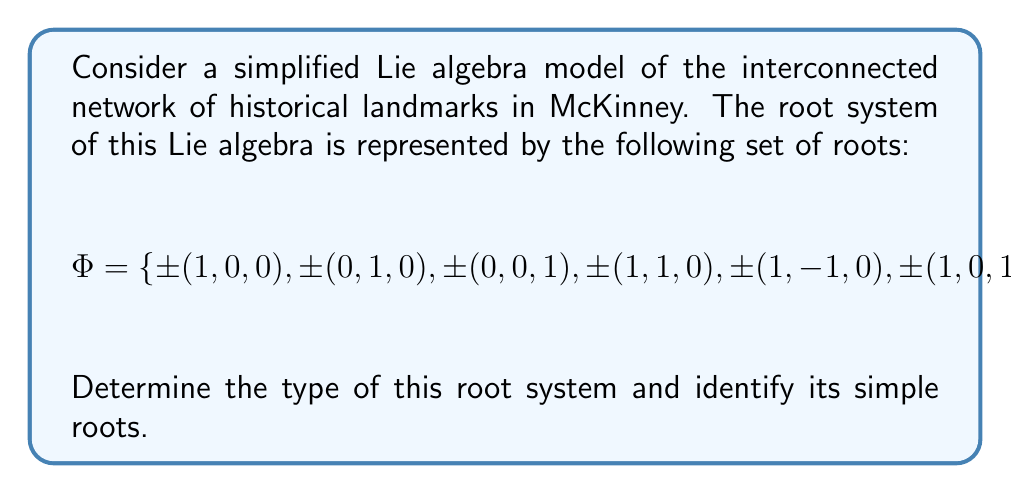Give your solution to this math problem. To analyze this root system and identify its type, we'll follow these steps:

1) First, we need to identify the rank of the system. The rank is the dimension of the space in which the roots live. Here, we have 3-dimensional vectors, so the rank is 3.

2) Next, we observe that the root system contains roots of two different lengths: 
   - Short roots: $\pm(1,0,0)$, $\pm(0,1,0)$, $\pm(0,0,1)$
   - Long roots: $\pm(1,1,0)$, $\pm(1,-1,0)$, $\pm(1,0,1)$, $\pm(1,0,-1)$

3) The presence of roots with two different lengths and the fact that the rank is 3 suggests that this is a root system of type $B_3$ or $C_3$. To distinguish between these, we need to count the number of short and long roots:
   - 6 short roots
   - 8 long roots

4) In a $B_3$ system, there are more short roots than long roots, while in a $C_3$ system, there are more long roots than short roots. Therefore, this is a $C_3$ root system.

5) To identify the simple roots, we need to choose a set of 3 roots (since the rank is 3) such that every root in the system can be written as an integer linear combination of these simple roots, with either all non-negative or all non-positive coefficients.

6) A possible choice for the simple roots is:
   $$\alpha_1 = (1,-1,0), \quad \alpha_2 = (0,1,-1), \quad \alpha_3 = (0,0,1)$$

7) We can verify that all other roots can be expressed as integer linear combinations of these simple roots. For example:
   $$(1,0,0) = \alpha_1 + \alpha_2 + \alpha_3$$
   $$(1,1,0) = \alpha_1 + 2\alpha_2 + 2\alpha_3$$

Therefore, the root system is of type $C_3$, with simple roots $\alpha_1 = (1,-1,0)$, $\alpha_2 = (0,1,-1)$, and $\alpha_3 = (0,0,1)$.
Answer: The root system is of type $C_3$. The simple roots are $\alpha_1 = (1,-1,0)$, $\alpha_2 = (0,1,-1)$, and $\alpha_3 = (0,0,1)$. 